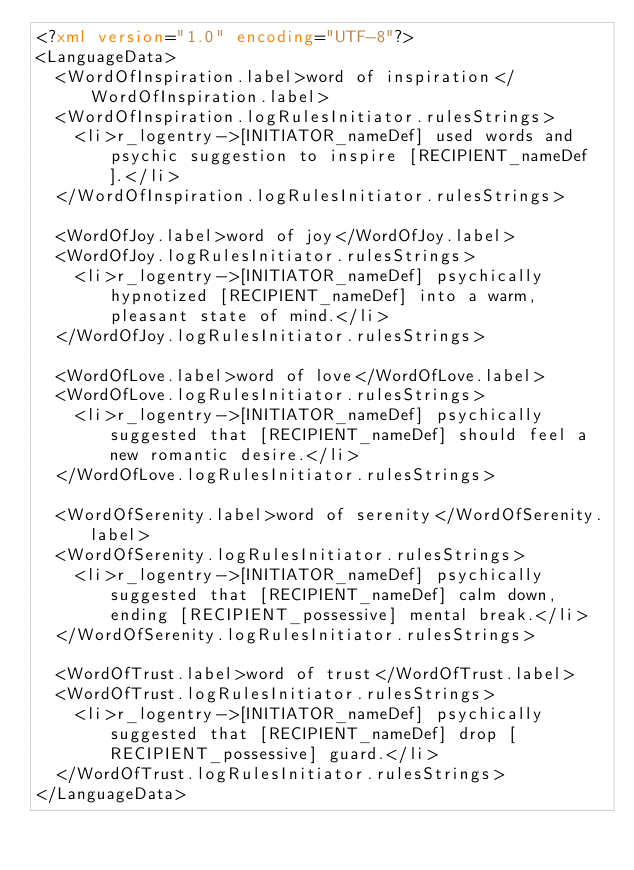Convert code to text. <code><loc_0><loc_0><loc_500><loc_500><_XML_><?xml version="1.0" encoding="UTF-8"?>
<LanguageData>
  <WordOfInspiration.label>word of inspiration</WordOfInspiration.label>
  <WordOfInspiration.logRulesInitiator.rulesStrings>
    <li>r_logentry->[INITIATOR_nameDef] used words and psychic suggestion to inspire [RECIPIENT_nameDef].</li>
  </WordOfInspiration.logRulesInitiator.rulesStrings>
  
  <WordOfJoy.label>word of joy</WordOfJoy.label>
  <WordOfJoy.logRulesInitiator.rulesStrings>
    <li>r_logentry->[INITIATOR_nameDef] psychically hypnotized [RECIPIENT_nameDef] into a warm, pleasant state of mind.</li>
  </WordOfJoy.logRulesInitiator.rulesStrings>
  
  <WordOfLove.label>word of love</WordOfLove.label>
  <WordOfLove.logRulesInitiator.rulesStrings>
    <li>r_logentry->[INITIATOR_nameDef] psychically suggested that [RECIPIENT_nameDef] should feel a new romantic desire.</li>
  </WordOfLove.logRulesInitiator.rulesStrings>
  
  <WordOfSerenity.label>word of serenity</WordOfSerenity.label>
  <WordOfSerenity.logRulesInitiator.rulesStrings>
    <li>r_logentry->[INITIATOR_nameDef] psychically suggested that [RECIPIENT_nameDef] calm down, ending [RECIPIENT_possessive] mental break.</li>
  </WordOfSerenity.logRulesInitiator.rulesStrings>
  
  <WordOfTrust.label>word of trust</WordOfTrust.label>
  <WordOfTrust.logRulesInitiator.rulesStrings>
    <li>r_logentry->[INITIATOR_nameDef] psychically suggested that [RECIPIENT_nameDef] drop [RECIPIENT_possessive] guard.</li>
  </WordOfTrust.logRulesInitiator.rulesStrings>
</LanguageData></code> 